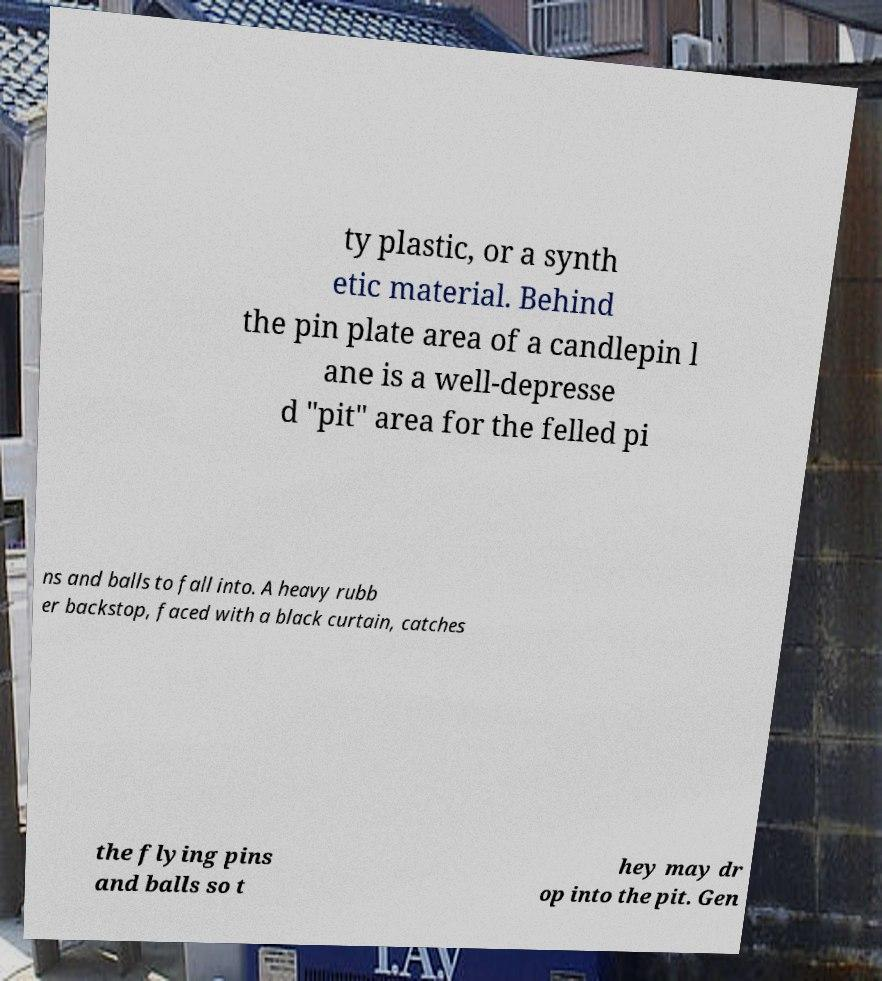Please identify and transcribe the text found in this image. ty plastic, or a synth etic material. Behind the pin plate area of a candlepin l ane is a well-depresse d "pit" area for the felled pi ns and balls to fall into. A heavy rubb er backstop, faced with a black curtain, catches the flying pins and balls so t hey may dr op into the pit. Gen 